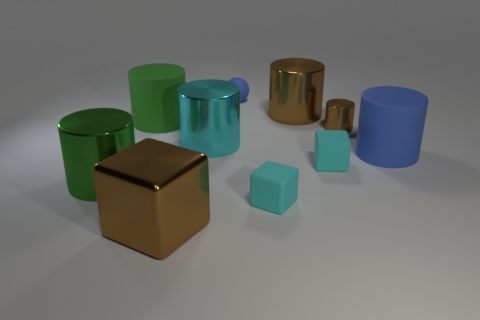Subtract 3 cylinders. How many cylinders are left? 3 Subtract all big rubber cylinders. How many cylinders are left? 4 Subtract all blue cylinders. How many cylinders are left? 5 Subtract all red cylinders. Subtract all purple balls. How many cylinders are left? 6 Subtract all spheres. How many objects are left? 9 Subtract all large green rubber cylinders. Subtract all green things. How many objects are left? 7 Add 1 blue matte cylinders. How many blue matte cylinders are left? 2 Add 3 large blue matte things. How many large blue matte things exist? 4 Subtract 0 green spheres. How many objects are left? 10 